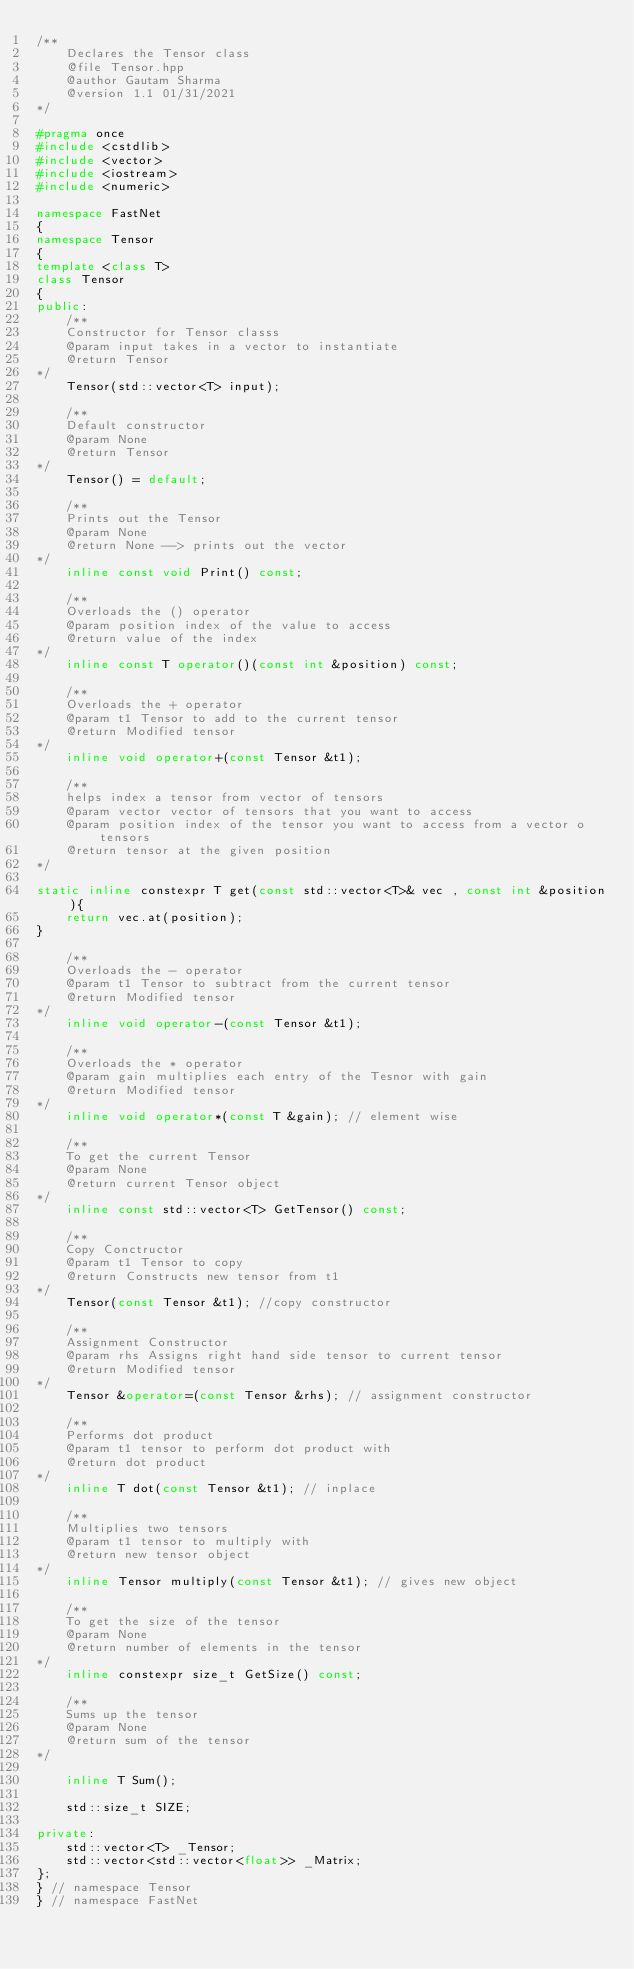Convert code to text. <code><loc_0><loc_0><loc_500><loc_500><_C++_>/**
    Declares the Tensor class
    @file Tensor.hpp
    @author Gautam Sharma
    @version 1.1 01/31/2021
*/

#pragma once
#include <cstdlib>
#include <vector>
#include <iostream>
#include <numeric>

namespace FastNet
{
namespace Tensor
{
template <class T>
class Tensor
{
public:
    /**
    Constructor for Tensor classs 
    @param input takes in a vector to instantiate
    @return Tensor
*/
    Tensor(std::vector<T> input);

    /**
    Default constructor
    @param None 
    @return Tensor
*/
    Tensor() = default;

    /**
    Prints out the Tensor
    @param None
    @return None --> prints out the vector
*/
    inline const void Print() const;

    /**
    Overloads the () operator
    @param position index of the value to access
    @return value of the index
*/
    inline const T operator()(const int &position) const;

    /**
    Overloads the + operator
    @param t1 Tensor to add to the current tensor
    @return Modified tensor 
*/
    inline void operator+(const Tensor &t1);

    /**
    helps index a tensor from vector of tensors
    @param vector vector of tensors that you want to access 
    @param position index of the tensor you want to access from a vector o tensors
    @return tensor at the given position
*/

static inline constexpr T get(const std::vector<T>& vec , const int &position){
    return vec.at(position);
}
 
    /**
    Overloads the - operator
    @param t1 Tensor to subtract from the current tensor
    @return Modified tensor 
*/
    inline void operator-(const Tensor &t1);

    /**
    Overloads the * operator
    @param gain multiplies each entry of the Tesnor with gain
    @return Modified tensor 
*/
    inline void operator*(const T &gain); // element wise

    /**
    To get the current Tensor
    @param None
    @return current Tensor object
*/
    inline const std::vector<T> GetTensor() const;

    /**
    Copy Conctructor
    @param t1 Tensor to copy 
    @return Constructs new tensor from t1
*/
    Tensor(const Tensor &t1); //copy constructor

    /**
    Assignment Constructor
    @param rhs Assigns right hand side tensor to current tensor
    @return Modified tensor
*/
    Tensor &operator=(const Tensor &rhs); // assignment constructor

    /**
    Performs dot product
    @param t1 tensor to perform dot product with
    @return dot product
*/
    inline T dot(const Tensor &t1); // inplace

    /**
    Multiplies two tensors
    @param t1 tensor to multiply with
    @return new tensor object
*/
    inline Tensor multiply(const Tensor &t1); // gives new object

    /**
    To get the size of the tensor
    @param None
    @return number of elements in the tensor
*/
    inline constexpr size_t GetSize() const;

    /**
    Sums up the tensor
    @param None
    @return sum of the tensor
*/

    inline T Sum();

    std::size_t SIZE;

private:
    std::vector<T> _Tensor;
    std::vector<std::vector<float>> _Matrix;
};
} // namespace Tensor
} // namespace FastNet</code> 